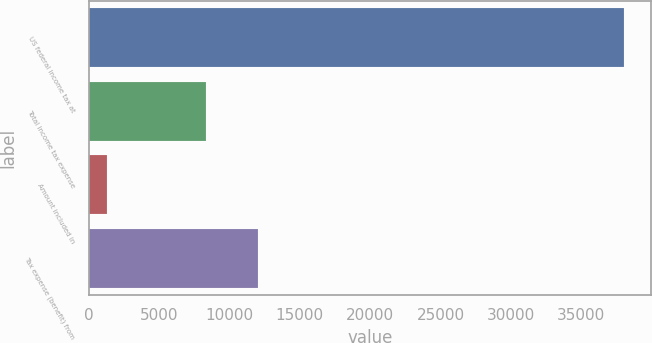Convert chart. <chart><loc_0><loc_0><loc_500><loc_500><bar_chart><fcel>US federal income tax at<fcel>Total income tax expense<fcel>Amount included in<fcel>Tax expense (benefit) from<nl><fcel>38065<fcel>8374<fcel>1309<fcel>12049.6<nl></chart> 